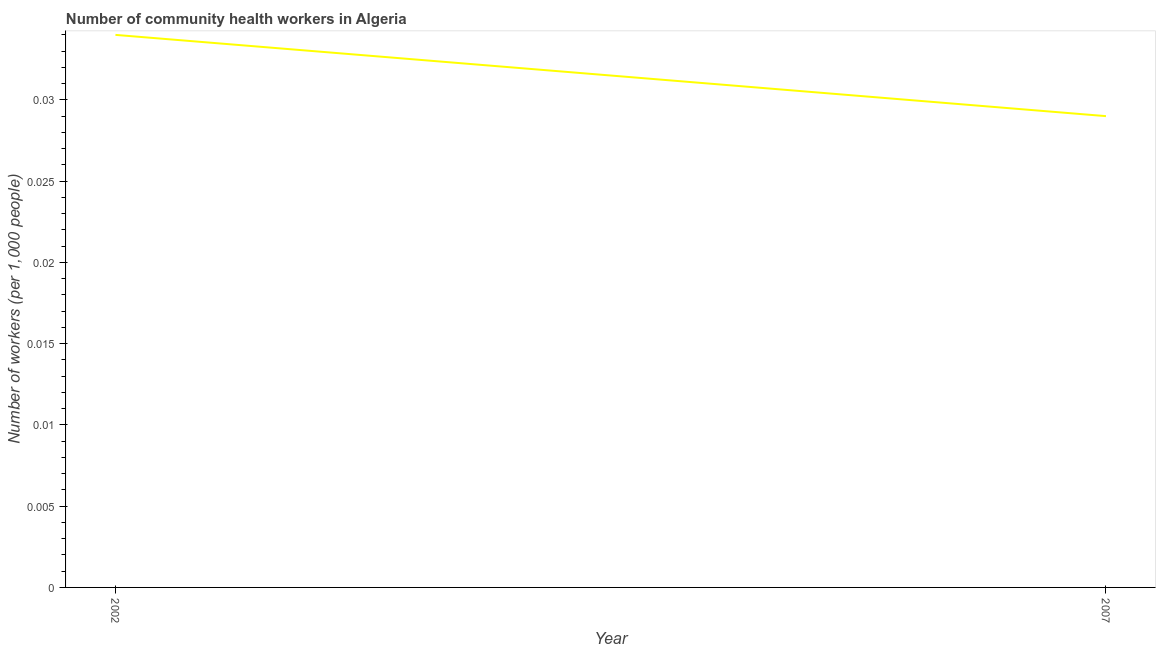What is the number of community health workers in 2007?
Your answer should be very brief. 0.03. Across all years, what is the maximum number of community health workers?
Offer a very short reply. 0.03. Across all years, what is the minimum number of community health workers?
Your answer should be compact. 0.03. In which year was the number of community health workers maximum?
Your response must be concise. 2002. In which year was the number of community health workers minimum?
Offer a terse response. 2007. What is the sum of the number of community health workers?
Your response must be concise. 0.06. What is the difference between the number of community health workers in 2002 and 2007?
Offer a very short reply. 0.01. What is the average number of community health workers per year?
Offer a very short reply. 0.03. What is the median number of community health workers?
Keep it short and to the point. 0.03. Do a majority of the years between 2002 and 2007 (inclusive) have number of community health workers greater than 0.03 ?
Your response must be concise. No. What is the ratio of the number of community health workers in 2002 to that in 2007?
Provide a succinct answer. 1.17. Is the number of community health workers in 2002 less than that in 2007?
Your response must be concise. No. In how many years, is the number of community health workers greater than the average number of community health workers taken over all years?
Keep it short and to the point. 1. How many lines are there?
Your answer should be very brief. 1. What is the difference between two consecutive major ticks on the Y-axis?
Give a very brief answer. 0.01. Does the graph contain any zero values?
Provide a short and direct response. No. What is the title of the graph?
Your answer should be very brief. Number of community health workers in Algeria. What is the label or title of the X-axis?
Provide a succinct answer. Year. What is the label or title of the Y-axis?
Give a very brief answer. Number of workers (per 1,0 people). What is the Number of workers (per 1,000 people) in 2002?
Keep it short and to the point. 0.03. What is the Number of workers (per 1,000 people) of 2007?
Ensure brevity in your answer.  0.03. What is the difference between the Number of workers (per 1,000 people) in 2002 and 2007?
Provide a short and direct response. 0.01. What is the ratio of the Number of workers (per 1,000 people) in 2002 to that in 2007?
Offer a very short reply. 1.17. 